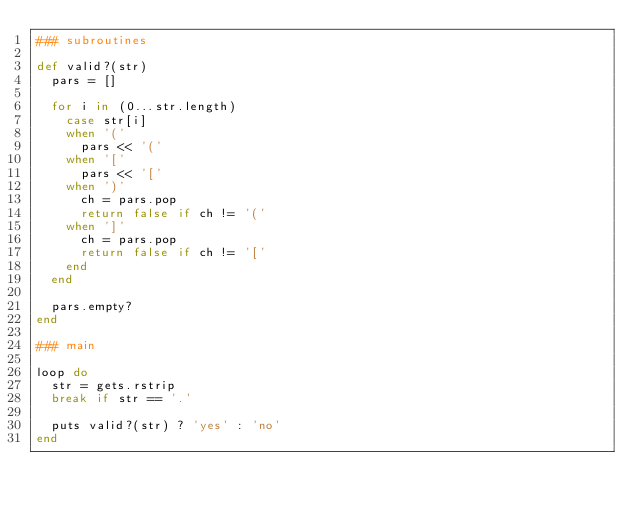Convert code to text. <code><loc_0><loc_0><loc_500><loc_500><_Ruby_>### subroutines

def valid?(str)
  pars = []

  for i in (0...str.length)
    case str[i]
    when '('
      pars << '('
    when '['
      pars << '['
    when ')'
      ch = pars.pop
      return false if ch != '('
    when ']'
      ch = pars.pop
      return false if ch != '['
    end
  end

  pars.empty?
end

### main

loop do
  str = gets.rstrip
  break if str == '.'

  puts valid?(str) ? 'yes' : 'no'
end</code> 